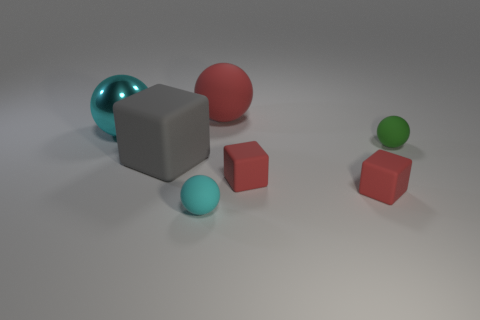Add 2 red blocks. How many objects exist? 9 Subtract all blocks. How many objects are left? 4 Subtract all yellow spheres. Subtract all gray matte cubes. How many objects are left? 6 Add 4 red rubber things. How many red rubber things are left? 7 Add 5 big brown shiny spheres. How many big brown shiny spheres exist? 5 Subtract 0 purple cylinders. How many objects are left? 7 